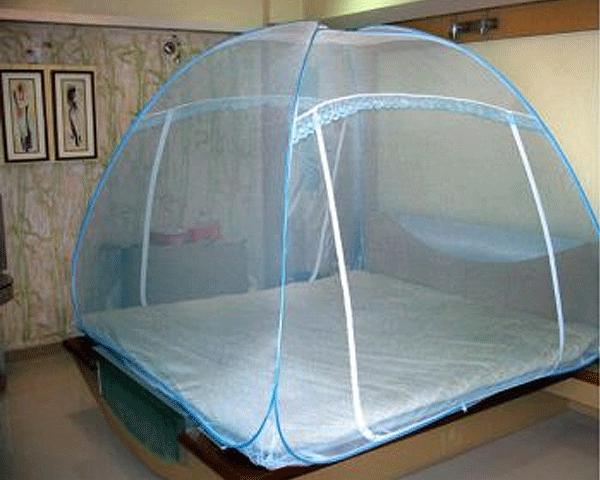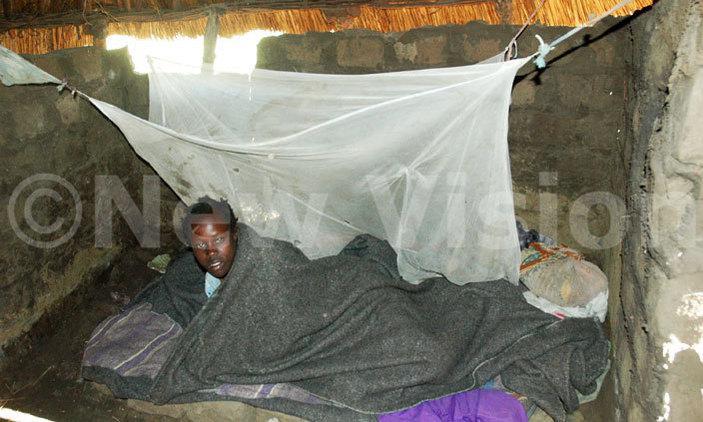The first image is the image on the left, the second image is the image on the right. For the images shown, is this caption "Two or more humans are visible." true? Answer yes or no. No. The first image is the image on the left, the second image is the image on the right. Examine the images to the left and right. Is the description "There are two square canopies with at least two people near it." accurate? Answer yes or no. No. 